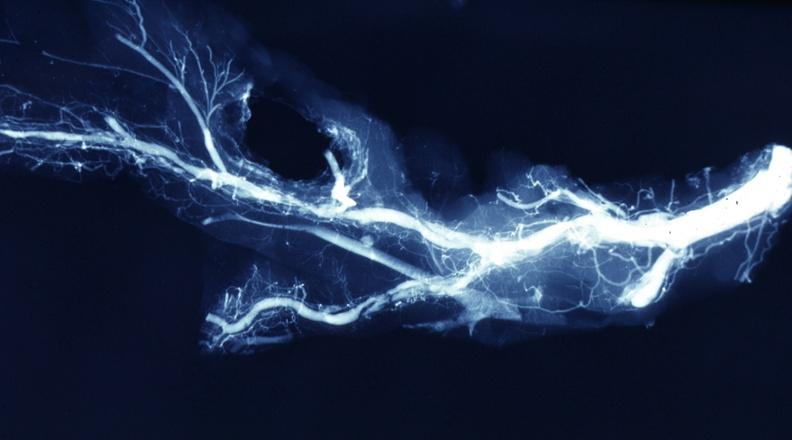s coronary artery present?
Answer the question using a single word or phrase. Yes 